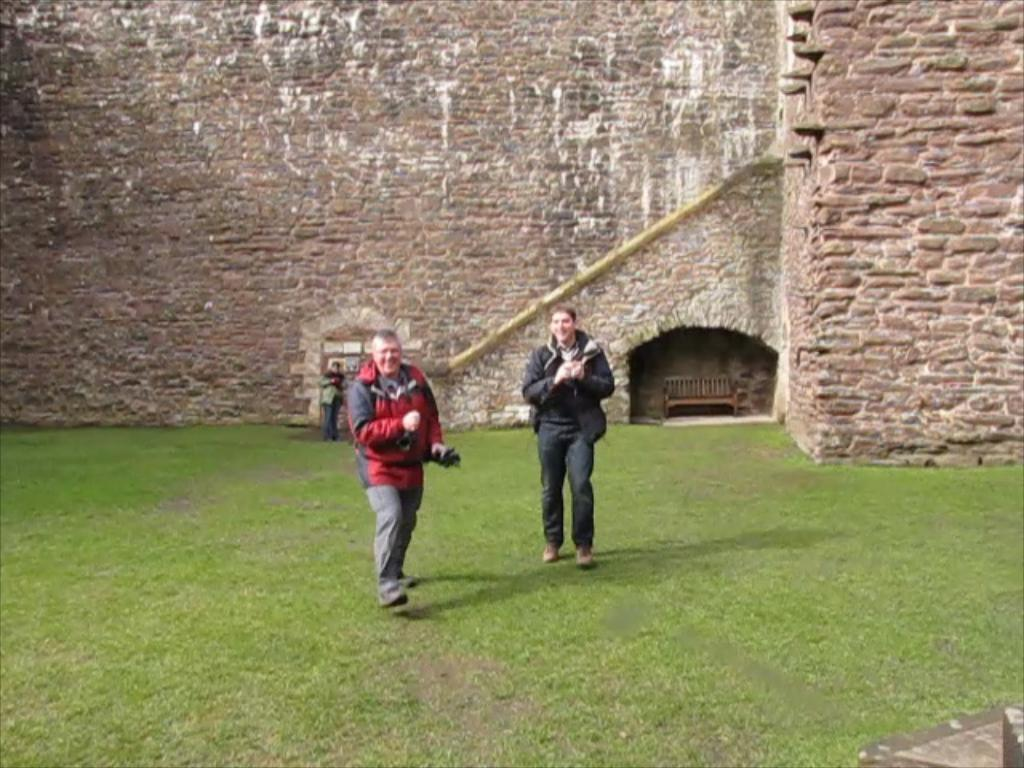How many people are in the image? There are three people in the image. Where are the people standing? The people are standing on the grass. What can be seen in the background of the image? There is a wall and a wooden bench in the background of the image. What type of property can be seen in the image? There is no property visible in the image; it only shows three people standing on the grass with a wall and a wooden bench in the background. 